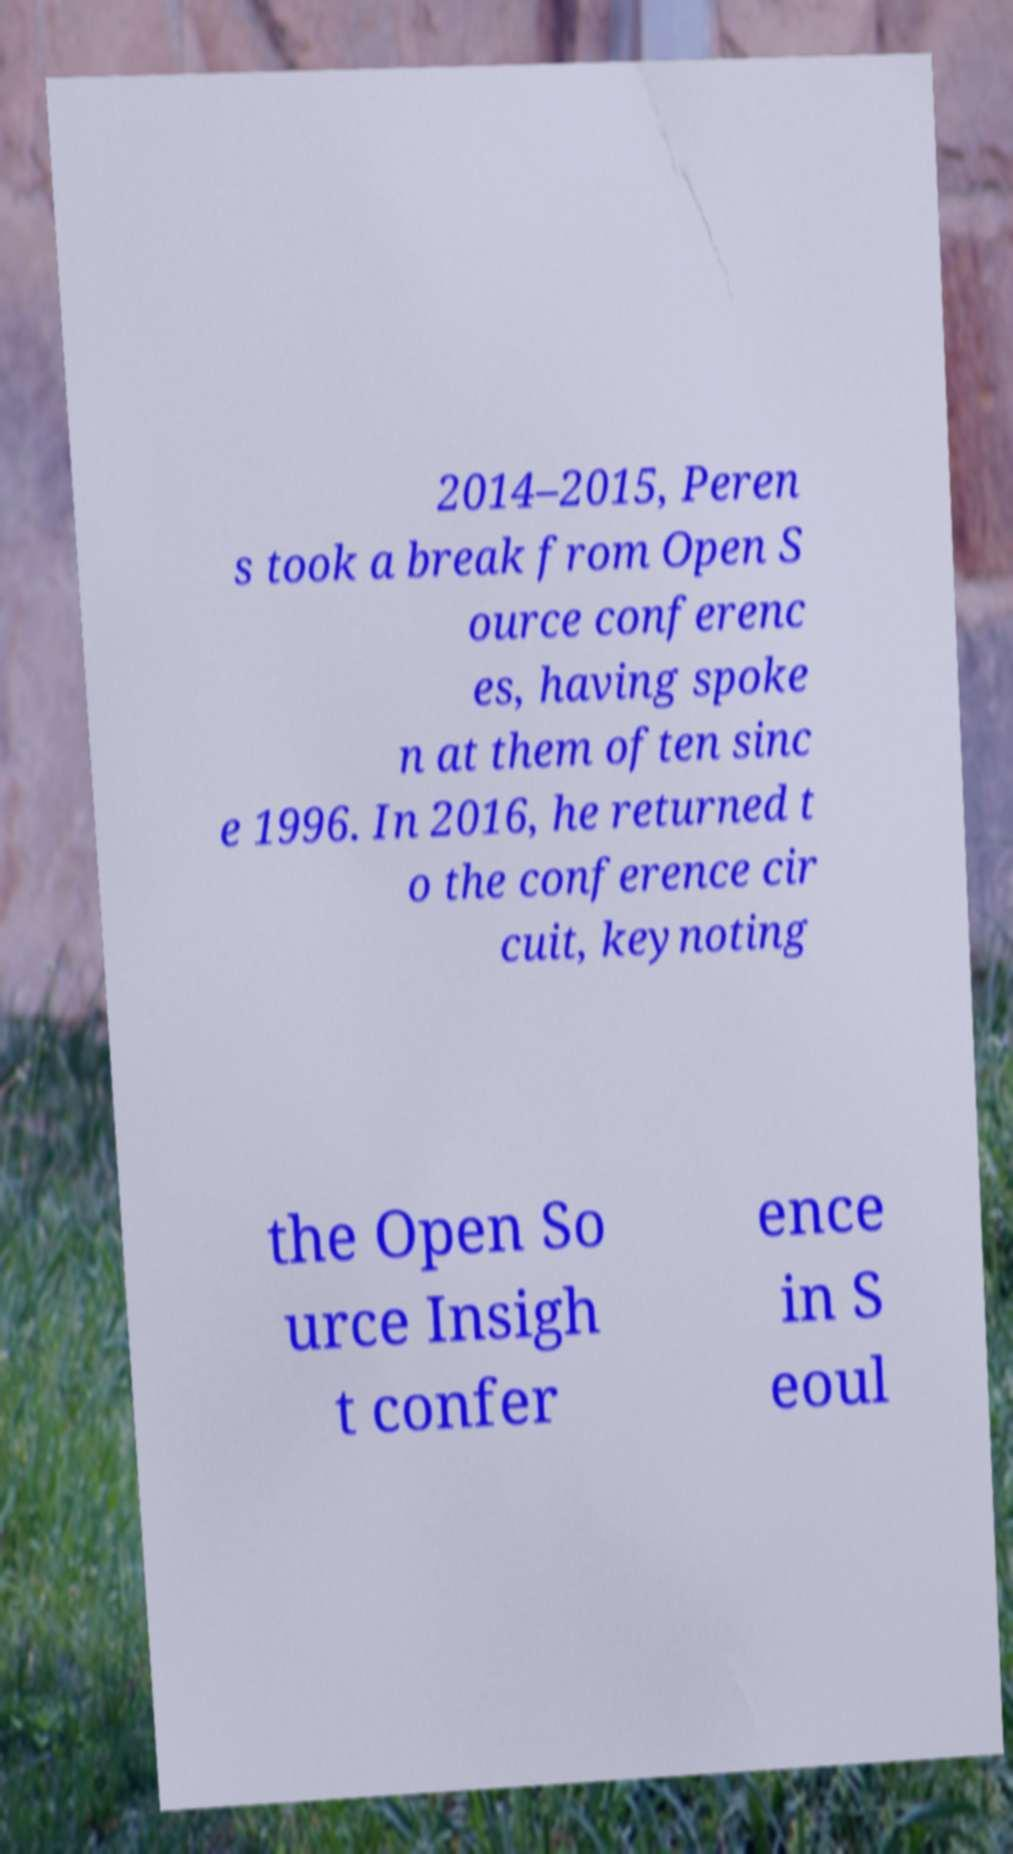There's text embedded in this image that I need extracted. Can you transcribe it verbatim? 2014–2015, Peren s took a break from Open S ource conferenc es, having spoke n at them often sinc e 1996. In 2016, he returned t o the conference cir cuit, keynoting the Open So urce Insigh t confer ence in S eoul 